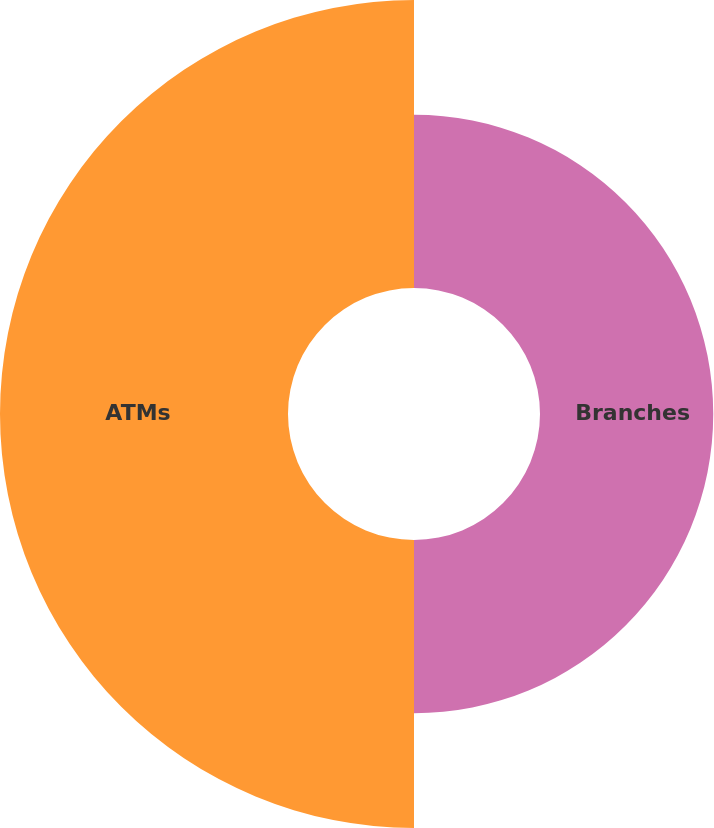Convert chart to OTSL. <chart><loc_0><loc_0><loc_500><loc_500><pie_chart><fcel>Branches<fcel>ATMs<nl><fcel>37.56%<fcel>62.44%<nl></chart> 